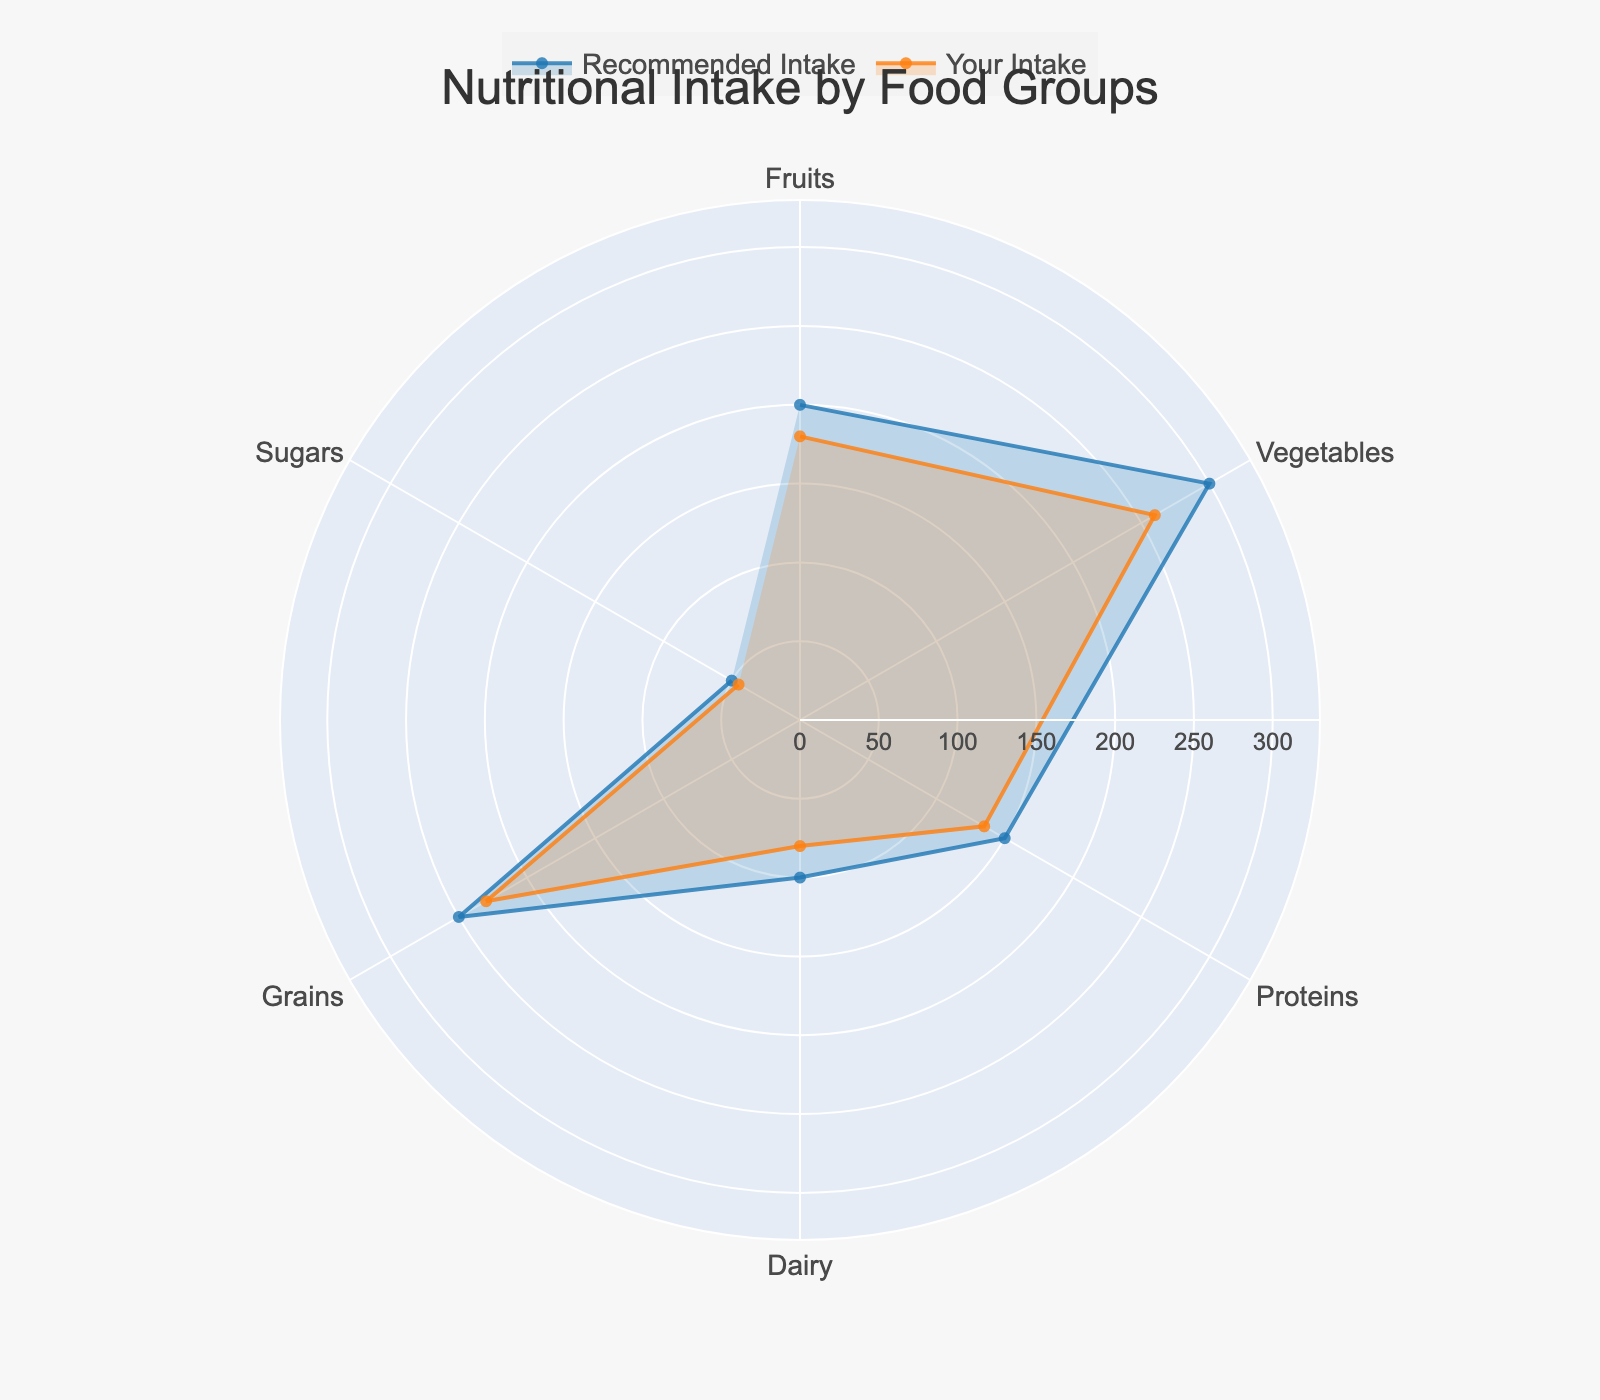What's the intake of vegetables compared to the recommended amount? On the radar chart, the intake of vegetables is shown as a certain distance from the center, and the recommended amount is displayed as another distance. By looking at the placement on the chart, we can see that "Your Intake" is less than the "Recommended Intake". Specifically, you consume 260g/day compared to the recommended 300g/day.
Answer: 260g vs. 300g Which food group has the smallest difference between your intake and the recommended intake? To find this, we need to calculate the difference for each food group: Fruits (20g), Vegetables (40g), Proteins (15g), Dairy (20g), Grains (20g), and Sugars (5g). The smallest difference is for the Sugars category, with only a 5g difference.
Answer: Sugars Which food group do you consume the most in? By looking at the chart, we can see which line (representing "Your Intake") extends farthest from the center. Comparing all groups, the Grains category has the highest intake at 230g/day.
Answer: Grains Do you consume more dairy or more protein? By comparing the "Your Intake" markers for both Dairy and Proteins on the radar chart, we can see that the Protein intake (135g) is higher than Dairy intake (80g).
Answer: Proteins What's the total recommended daily intake for all food groups? To find the total recommended intake, sum the recommended values for all categories: 200g (Fruits) + 300g (Vegetables) + 150g (Proteins) + 100g (Dairy) + 250g (Grains) + 50g (Sugars) = 1050g.
Answer: 1050g Which intake category is closest to its recommended value? By comparing the intake and recommended values for each food group, the Sugars category has the closest intake to the recommended value (45g vs. 50g), with only a 5g difference.
Answer: Sugars Are there any categories where your intake exceeds the recommended amount? On the radar chart, if “Your Intake” plot exceeds the “Recommended Intake” plot for any food group, it indicates overconsumption. By reviewing the chart, no category has an intake that exceeds the recommended value.
Answer: No How does your intake of proteins compare with that of fruits and vegetables combined? Summing the intake of Fruits (180g) and Vegetables (260g) gives us a total of 440g. Comparing this to your Protein intake of 135g, your intake of Fruits and Vegetables combined is significantly higher.
Answer: Fruits & Vegetables combined Which food group has the least intake according to your chart? By identifying which section of "Your Intake" extends least from the center, the least intake category is Sugars at 45g/day.
Answer: Sugars 